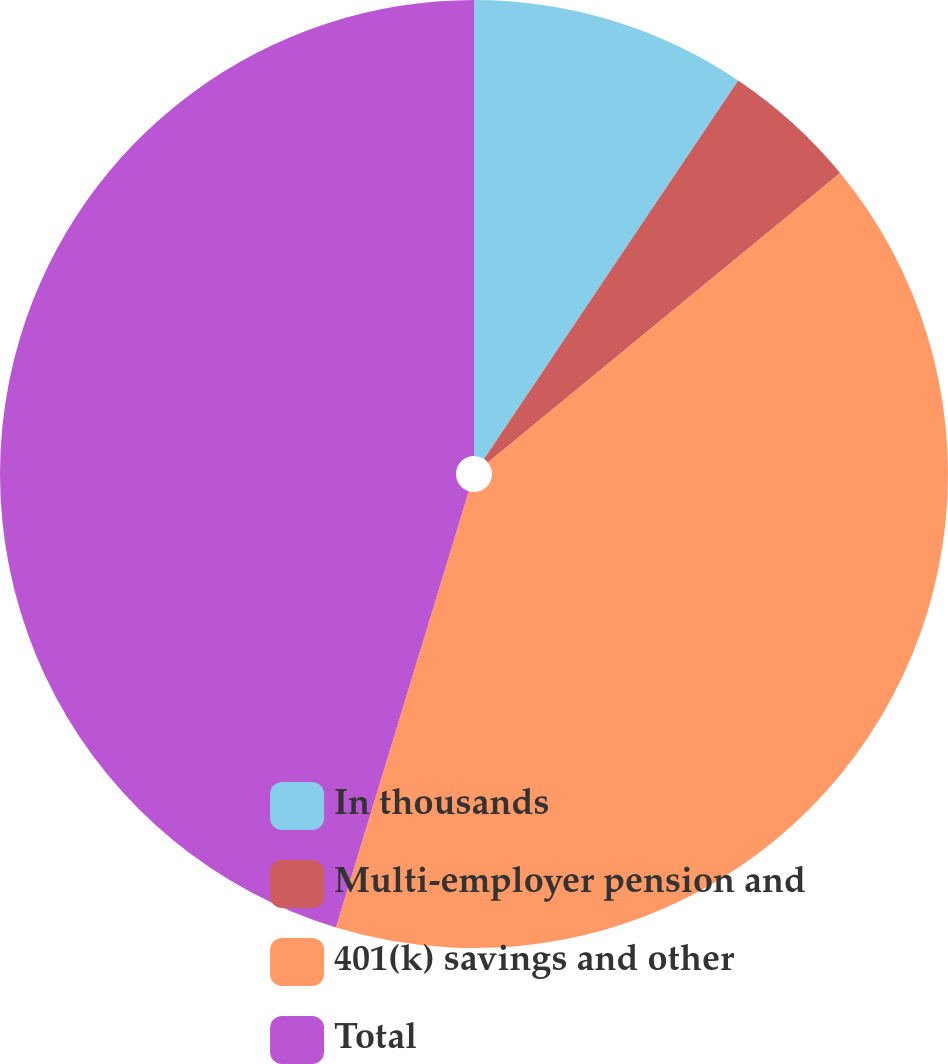Convert chart. <chart><loc_0><loc_0><loc_500><loc_500><pie_chart><fcel>In thousands<fcel>Multi-employer pension and<fcel>401(k) savings and other<fcel>Total<nl><fcel>9.41%<fcel>4.64%<fcel>40.66%<fcel>45.3%<nl></chart> 